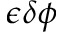Convert formula to latex. <formula><loc_0><loc_0><loc_500><loc_500>\epsilon \delta \phi</formula> 